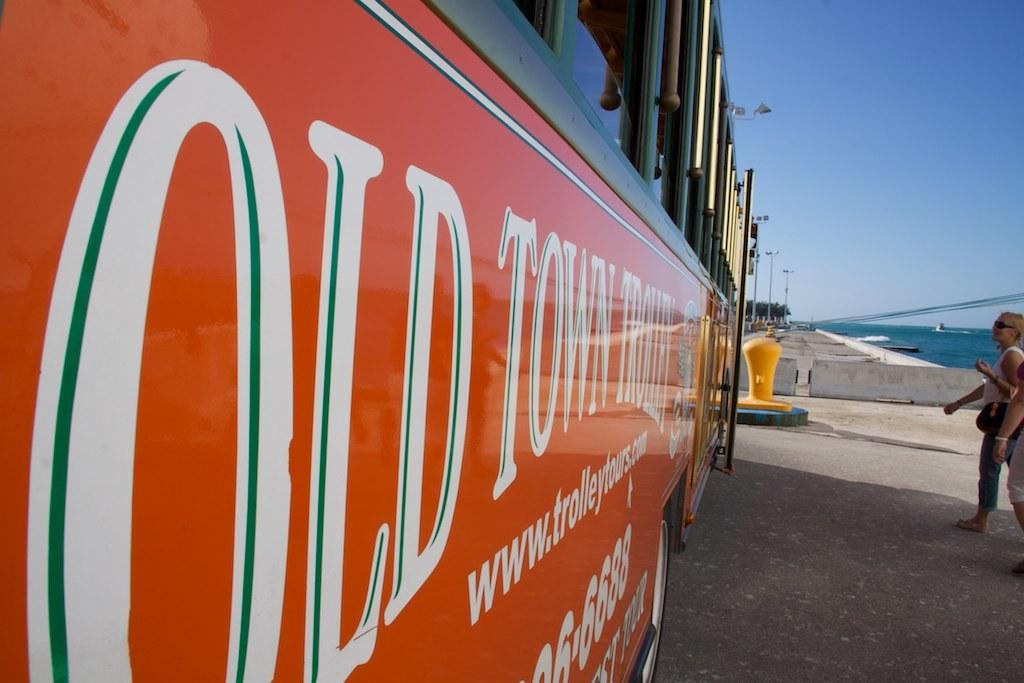Provide a one-sentence caption for the provided image. A sign on a trolley that has the website www.trolleytours.com on it. 